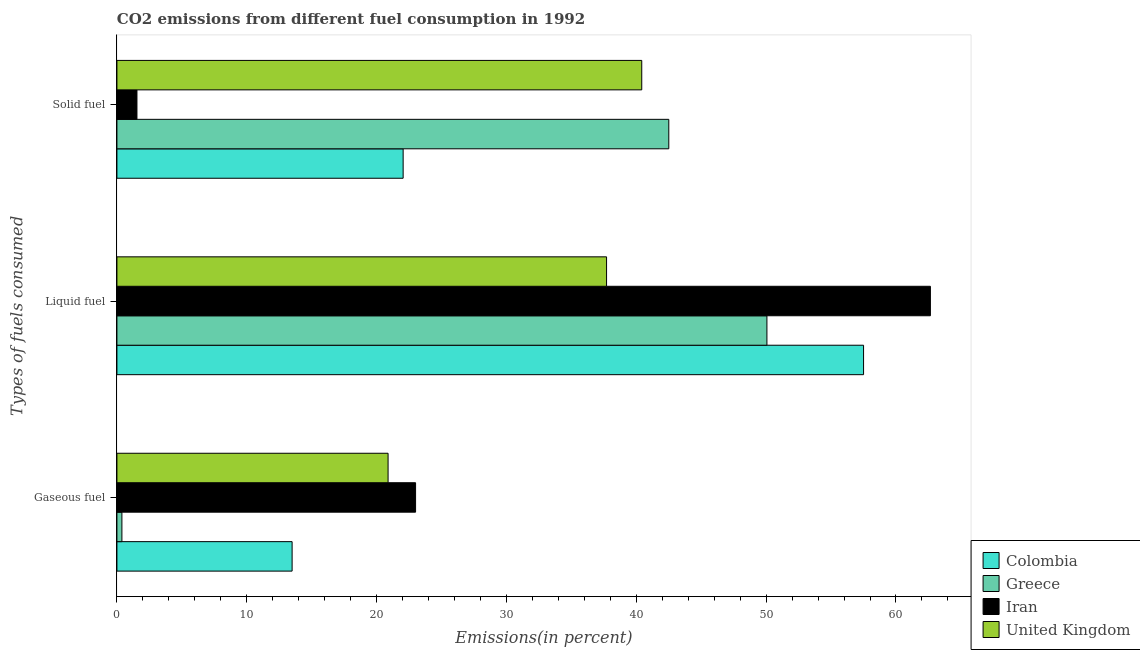How many different coloured bars are there?
Give a very brief answer. 4. How many bars are there on the 2nd tick from the top?
Your answer should be very brief. 4. How many bars are there on the 1st tick from the bottom?
Your answer should be compact. 4. What is the label of the 3rd group of bars from the top?
Provide a succinct answer. Gaseous fuel. What is the percentage of liquid fuel emission in Colombia?
Provide a succinct answer. 57.5. Across all countries, what is the maximum percentage of solid fuel emission?
Provide a succinct answer. 42.5. Across all countries, what is the minimum percentage of solid fuel emission?
Give a very brief answer. 1.54. In which country was the percentage of liquid fuel emission maximum?
Provide a succinct answer. Iran. In which country was the percentage of liquid fuel emission minimum?
Provide a short and direct response. United Kingdom. What is the total percentage of solid fuel emission in the graph?
Keep it short and to the point. 106.51. What is the difference between the percentage of gaseous fuel emission in United Kingdom and that in Colombia?
Provide a short and direct response. 7.39. What is the difference between the percentage of solid fuel emission in Colombia and the percentage of liquid fuel emission in United Kingdom?
Make the answer very short. -15.67. What is the average percentage of gaseous fuel emission per country?
Offer a very short reply. 14.44. What is the difference between the percentage of solid fuel emission and percentage of gaseous fuel emission in Greece?
Provide a succinct answer. 42.12. What is the ratio of the percentage of gaseous fuel emission in United Kingdom to that in Colombia?
Provide a short and direct response. 1.55. Is the difference between the percentage of liquid fuel emission in Colombia and United Kingdom greater than the difference between the percentage of gaseous fuel emission in Colombia and United Kingdom?
Give a very brief answer. Yes. What is the difference between the highest and the second highest percentage of liquid fuel emission?
Offer a terse response. 5.15. What is the difference between the highest and the lowest percentage of solid fuel emission?
Offer a terse response. 40.96. What does the 4th bar from the top in Solid fuel represents?
Offer a very short reply. Colombia. What does the 3rd bar from the bottom in Liquid fuel represents?
Provide a short and direct response. Iran. How many bars are there?
Offer a terse response. 12. How many countries are there in the graph?
Your answer should be very brief. 4. What is the difference between two consecutive major ticks on the X-axis?
Offer a very short reply. 10. Are the values on the major ticks of X-axis written in scientific E-notation?
Your response must be concise. No. How many legend labels are there?
Keep it short and to the point. 4. How are the legend labels stacked?
Offer a terse response. Vertical. What is the title of the graph?
Offer a very short reply. CO2 emissions from different fuel consumption in 1992. Does "Gabon" appear as one of the legend labels in the graph?
Give a very brief answer. No. What is the label or title of the X-axis?
Your answer should be very brief. Emissions(in percent). What is the label or title of the Y-axis?
Your answer should be compact. Types of fuels consumed. What is the Emissions(in percent) in Colombia in Gaseous fuel?
Keep it short and to the point. 13.49. What is the Emissions(in percent) in Greece in Gaseous fuel?
Give a very brief answer. 0.38. What is the Emissions(in percent) of Iran in Gaseous fuel?
Make the answer very short. 23. What is the Emissions(in percent) of United Kingdom in Gaseous fuel?
Ensure brevity in your answer.  20.88. What is the Emissions(in percent) of Colombia in Liquid fuel?
Give a very brief answer. 57.5. What is the Emissions(in percent) in Greece in Liquid fuel?
Keep it short and to the point. 50.06. What is the Emissions(in percent) of Iran in Liquid fuel?
Offer a terse response. 62.65. What is the Emissions(in percent) in United Kingdom in Liquid fuel?
Your answer should be very brief. 37.71. What is the Emissions(in percent) in Colombia in Solid fuel?
Your answer should be compact. 22.04. What is the Emissions(in percent) of Greece in Solid fuel?
Provide a succinct answer. 42.5. What is the Emissions(in percent) of Iran in Solid fuel?
Offer a very short reply. 1.54. What is the Emissions(in percent) of United Kingdom in Solid fuel?
Provide a short and direct response. 40.42. Across all Types of fuels consumed, what is the maximum Emissions(in percent) of Colombia?
Offer a very short reply. 57.5. Across all Types of fuels consumed, what is the maximum Emissions(in percent) of Greece?
Provide a succinct answer. 50.06. Across all Types of fuels consumed, what is the maximum Emissions(in percent) in Iran?
Keep it short and to the point. 62.65. Across all Types of fuels consumed, what is the maximum Emissions(in percent) in United Kingdom?
Your response must be concise. 40.42. Across all Types of fuels consumed, what is the minimum Emissions(in percent) of Colombia?
Keep it short and to the point. 13.49. Across all Types of fuels consumed, what is the minimum Emissions(in percent) in Greece?
Your response must be concise. 0.38. Across all Types of fuels consumed, what is the minimum Emissions(in percent) of Iran?
Make the answer very short. 1.54. Across all Types of fuels consumed, what is the minimum Emissions(in percent) in United Kingdom?
Keep it short and to the point. 20.88. What is the total Emissions(in percent) of Colombia in the graph?
Your answer should be very brief. 93.04. What is the total Emissions(in percent) of Greece in the graph?
Offer a terse response. 92.95. What is the total Emissions(in percent) in Iran in the graph?
Ensure brevity in your answer.  87.2. What is the total Emissions(in percent) of United Kingdom in the graph?
Your answer should be very brief. 99.01. What is the difference between the Emissions(in percent) of Colombia in Gaseous fuel and that in Liquid fuel?
Provide a short and direct response. -44.01. What is the difference between the Emissions(in percent) in Greece in Gaseous fuel and that in Liquid fuel?
Your answer should be compact. -49.68. What is the difference between the Emissions(in percent) in Iran in Gaseous fuel and that in Liquid fuel?
Your response must be concise. -39.65. What is the difference between the Emissions(in percent) in United Kingdom in Gaseous fuel and that in Liquid fuel?
Your answer should be very brief. -16.83. What is the difference between the Emissions(in percent) in Colombia in Gaseous fuel and that in Solid fuel?
Provide a short and direct response. -8.55. What is the difference between the Emissions(in percent) in Greece in Gaseous fuel and that in Solid fuel?
Give a very brief answer. -42.12. What is the difference between the Emissions(in percent) of Iran in Gaseous fuel and that in Solid fuel?
Your answer should be compact. 21.46. What is the difference between the Emissions(in percent) of United Kingdom in Gaseous fuel and that in Solid fuel?
Provide a succinct answer. -19.54. What is the difference between the Emissions(in percent) of Colombia in Liquid fuel and that in Solid fuel?
Make the answer very short. 35.46. What is the difference between the Emissions(in percent) of Greece in Liquid fuel and that in Solid fuel?
Give a very brief answer. 7.56. What is the difference between the Emissions(in percent) of Iran in Liquid fuel and that in Solid fuel?
Make the answer very short. 61.11. What is the difference between the Emissions(in percent) of United Kingdom in Liquid fuel and that in Solid fuel?
Your answer should be compact. -2.71. What is the difference between the Emissions(in percent) of Colombia in Gaseous fuel and the Emissions(in percent) of Greece in Liquid fuel?
Offer a very short reply. -36.57. What is the difference between the Emissions(in percent) of Colombia in Gaseous fuel and the Emissions(in percent) of Iran in Liquid fuel?
Give a very brief answer. -49.16. What is the difference between the Emissions(in percent) of Colombia in Gaseous fuel and the Emissions(in percent) of United Kingdom in Liquid fuel?
Your answer should be compact. -24.22. What is the difference between the Emissions(in percent) of Greece in Gaseous fuel and the Emissions(in percent) of Iran in Liquid fuel?
Keep it short and to the point. -62.27. What is the difference between the Emissions(in percent) of Greece in Gaseous fuel and the Emissions(in percent) of United Kingdom in Liquid fuel?
Ensure brevity in your answer.  -37.33. What is the difference between the Emissions(in percent) in Iran in Gaseous fuel and the Emissions(in percent) in United Kingdom in Liquid fuel?
Give a very brief answer. -14.71. What is the difference between the Emissions(in percent) in Colombia in Gaseous fuel and the Emissions(in percent) in Greece in Solid fuel?
Keep it short and to the point. -29.01. What is the difference between the Emissions(in percent) of Colombia in Gaseous fuel and the Emissions(in percent) of Iran in Solid fuel?
Give a very brief answer. 11.95. What is the difference between the Emissions(in percent) in Colombia in Gaseous fuel and the Emissions(in percent) in United Kingdom in Solid fuel?
Your answer should be very brief. -26.93. What is the difference between the Emissions(in percent) in Greece in Gaseous fuel and the Emissions(in percent) in Iran in Solid fuel?
Make the answer very short. -1.16. What is the difference between the Emissions(in percent) of Greece in Gaseous fuel and the Emissions(in percent) of United Kingdom in Solid fuel?
Your answer should be very brief. -40.04. What is the difference between the Emissions(in percent) in Iran in Gaseous fuel and the Emissions(in percent) in United Kingdom in Solid fuel?
Give a very brief answer. -17.42. What is the difference between the Emissions(in percent) of Colombia in Liquid fuel and the Emissions(in percent) of Greece in Solid fuel?
Offer a very short reply. 15. What is the difference between the Emissions(in percent) of Colombia in Liquid fuel and the Emissions(in percent) of Iran in Solid fuel?
Your answer should be very brief. 55.96. What is the difference between the Emissions(in percent) in Colombia in Liquid fuel and the Emissions(in percent) in United Kingdom in Solid fuel?
Make the answer very short. 17.08. What is the difference between the Emissions(in percent) of Greece in Liquid fuel and the Emissions(in percent) of Iran in Solid fuel?
Keep it short and to the point. 48.52. What is the difference between the Emissions(in percent) in Greece in Liquid fuel and the Emissions(in percent) in United Kingdom in Solid fuel?
Keep it short and to the point. 9.64. What is the difference between the Emissions(in percent) of Iran in Liquid fuel and the Emissions(in percent) of United Kingdom in Solid fuel?
Provide a short and direct response. 22.23. What is the average Emissions(in percent) of Colombia per Types of fuels consumed?
Provide a succinct answer. 31.01. What is the average Emissions(in percent) of Greece per Types of fuels consumed?
Offer a very short reply. 30.98. What is the average Emissions(in percent) of Iran per Types of fuels consumed?
Ensure brevity in your answer.  29.07. What is the average Emissions(in percent) in United Kingdom per Types of fuels consumed?
Your response must be concise. 33. What is the difference between the Emissions(in percent) in Colombia and Emissions(in percent) in Greece in Gaseous fuel?
Make the answer very short. 13.11. What is the difference between the Emissions(in percent) in Colombia and Emissions(in percent) in Iran in Gaseous fuel?
Give a very brief answer. -9.51. What is the difference between the Emissions(in percent) in Colombia and Emissions(in percent) in United Kingdom in Gaseous fuel?
Give a very brief answer. -7.39. What is the difference between the Emissions(in percent) of Greece and Emissions(in percent) of Iran in Gaseous fuel?
Ensure brevity in your answer.  -22.62. What is the difference between the Emissions(in percent) of Greece and Emissions(in percent) of United Kingdom in Gaseous fuel?
Provide a short and direct response. -20.5. What is the difference between the Emissions(in percent) of Iran and Emissions(in percent) of United Kingdom in Gaseous fuel?
Make the answer very short. 2.12. What is the difference between the Emissions(in percent) of Colombia and Emissions(in percent) of Greece in Liquid fuel?
Your answer should be compact. 7.44. What is the difference between the Emissions(in percent) in Colombia and Emissions(in percent) in Iran in Liquid fuel?
Offer a terse response. -5.15. What is the difference between the Emissions(in percent) in Colombia and Emissions(in percent) in United Kingdom in Liquid fuel?
Your response must be concise. 19.79. What is the difference between the Emissions(in percent) of Greece and Emissions(in percent) of Iran in Liquid fuel?
Make the answer very short. -12.59. What is the difference between the Emissions(in percent) in Greece and Emissions(in percent) in United Kingdom in Liquid fuel?
Provide a short and direct response. 12.35. What is the difference between the Emissions(in percent) in Iran and Emissions(in percent) in United Kingdom in Liquid fuel?
Offer a terse response. 24.94. What is the difference between the Emissions(in percent) in Colombia and Emissions(in percent) in Greece in Solid fuel?
Keep it short and to the point. -20.46. What is the difference between the Emissions(in percent) of Colombia and Emissions(in percent) of Iran in Solid fuel?
Provide a succinct answer. 20.5. What is the difference between the Emissions(in percent) in Colombia and Emissions(in percent) in United Kingdom in Solid fuel?
Offer a very short reply. -18.38. What is the difference between the Emissions(in percent) of Greece and Emissions(in percent) of Iran in Solid fuel?
Offer a very short reply. 40.96. What is the difference between the Emissions(in percent) in Greece and Emissions(in percent) in United Kingdom in Solid fuel?
Give a very brief answer. 2.08. What is the difference between the Emissions(in percent) of Iran and Emissions(in percent) of United Kingdom in Solid fuel?
Give a very brief answer. -38.88. What is the ratio of the Emissions(in percent) of Colombia in Gaseous fuel to that in Liquid fuel?
Make the answer very short. 0.23. What is the ratio of the Emissions(in percent) of Greece in Gaseous fuel to that in Liquid fuel?
Keep it short and to the point. 0.01. What is the ratio of the Emissions(in percent) of Iran in Gaseous fuel to that in Liquid fuel?
Offer a very short reply. 0.37. What is the ratio of the Emissions(in percent) in United Kingdom in Gaseous fuel to that in Liquid fuel?
Ensure brevity in your answer.  0.55. What is the ratio of the Emissions(in percent) of Colombia in Gaseous fuel to that in Solid fuel?
Your answer should be very brief. 0.61. What is the ratio of the Emissions(in percent) in Greece in Gaseous fuel to that in Solid fuel?
Provide a succinct answer. 0.01. What is the ratio of the Emissions(in percent) in Iran in Gaseous fuel to that in Solid fuel?
Provide a succinct answer. 14.91. What is the ratio of the Emissions(in percent) of United Kingdom in Gaseous fuel to that in Solid fuel?
Offer a very short reply. 0.52. What is the ratio of the Emissions(in percent) in Colombia in Liquid fuel to that in Solid fuel?
Give a very brief answer. 2.61. What is the ratio of the Emissions(in percent) of Greece in Liquid fuel to that in Solid fuel?
Offer a very short reply. 1.18. What is the ratio of the Emissions(in percent) of Iran in Liquid fuel to that in Solid fuel?
Provide a short and direct response. 40.6. What is the ratio of the Emissions(in percent) in United Kingdom in Liquid fuel to that in Solid fuel?
Your answer should be compact. 0.93. What is the difference between the highest and the second highest Emissions(in percent) of Colombia?
Offer a very short reply. 35.46. What is the difference between the highest and the second highest Emissions(in percent) of Greece?
Ensure brevity in your answer.  7.56. What is the difference between the highest and the second highest Emissions(in percent) of Iran?
Provide a succinct answer. 39.65. What is the difference between the highest and the second highest Emissions(in percent) of United Kingdom?
Offer a very short reply. 2.71. What is the difference between the highest and the lowest Emissions(in percent) of Colombia?
Provide a succinct answer. 44.01. What is the difference between the highest and the lowest Emissions(in percent) of Greece?
Offer a terse response. 49.68. What is the difference between the highest and the lowest Emissions(in percent) of Iran?
Ensure brevity in your answer.  61.11. What is the difference between the highest and the lowest Emissions(in percent) in United Kingdom?
Provide a succinct answer. 19.54. 